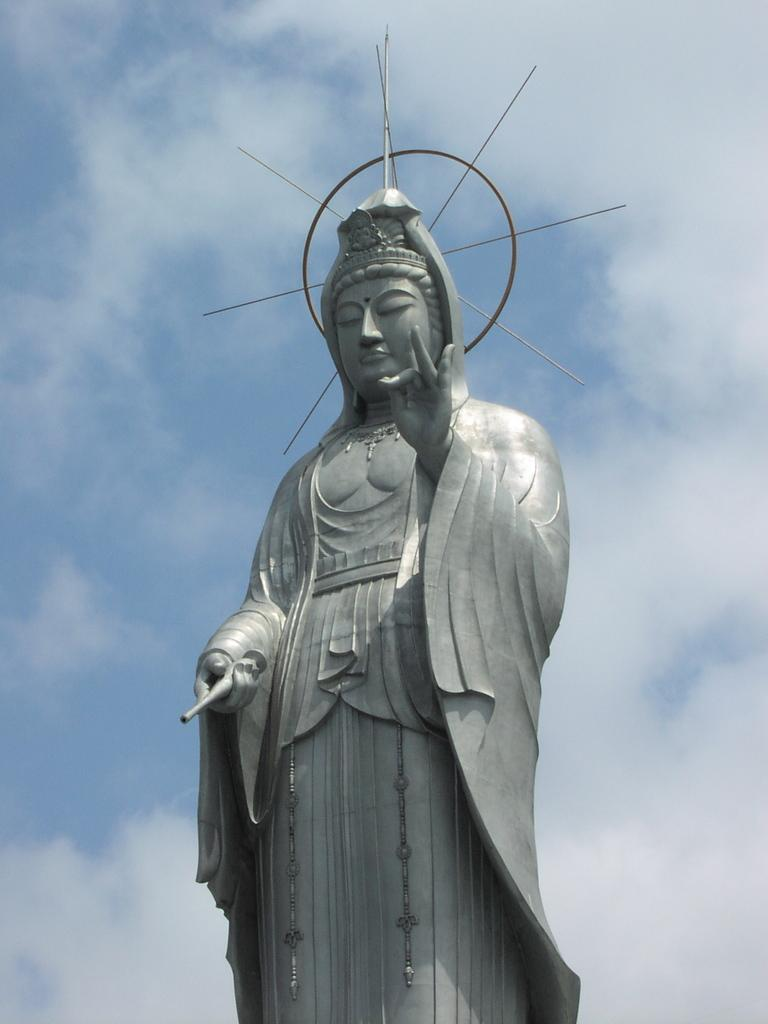What is the main subject of the image? There is a statue of a person in the image. What color is the statue? The statue is in ash color. What can be seen in the background of the image? There are clouds and the sky visible in the background of the image. Are there any cobwebs visible on the statue in the image? There is no mention of cobwebs in the provided facts, and therefore we cannot determine if any are present in the image. What hobbies does the person depicted in the statue enjoy? The image only shows a statue, and we cannot determine the person's hobbies from the image. 